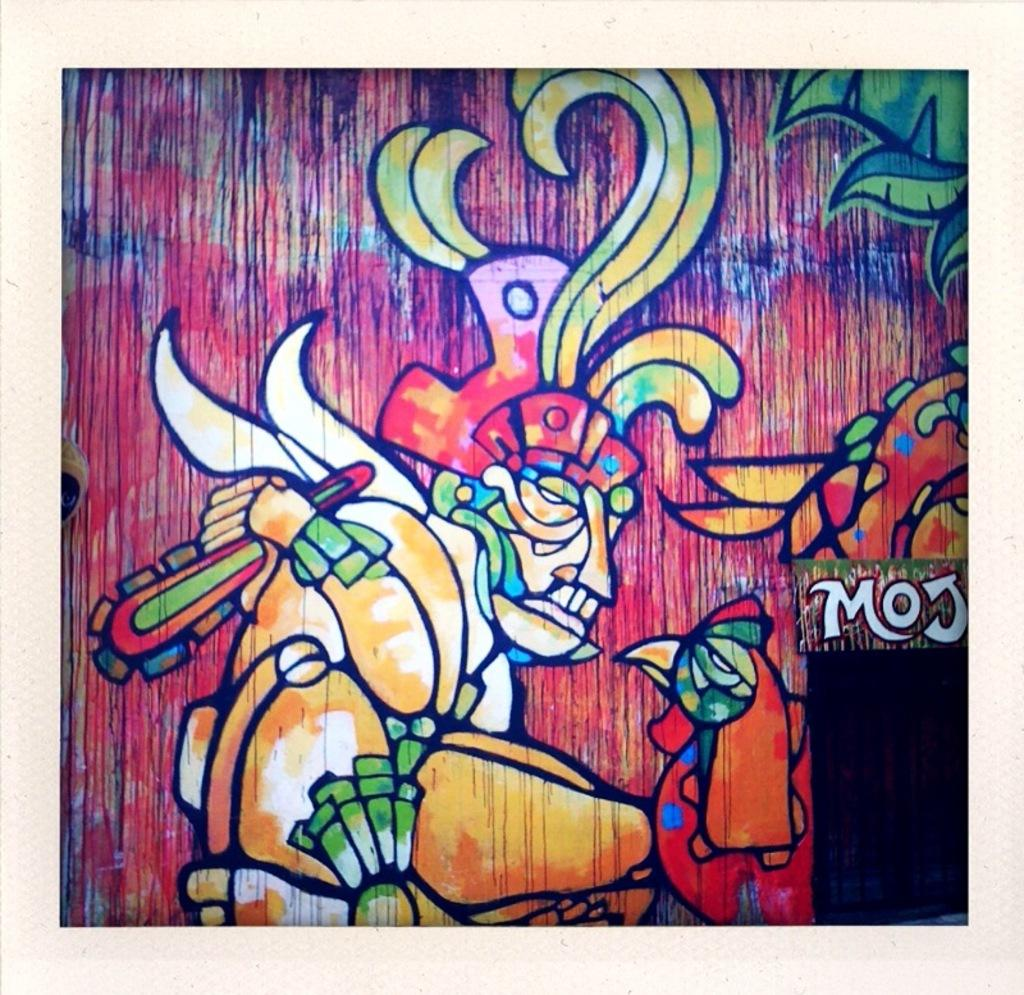<image>
Share a concise interpretation of the image provided. An artistic painting of a tribal man standing next to a rooster with the name moj on the side. 